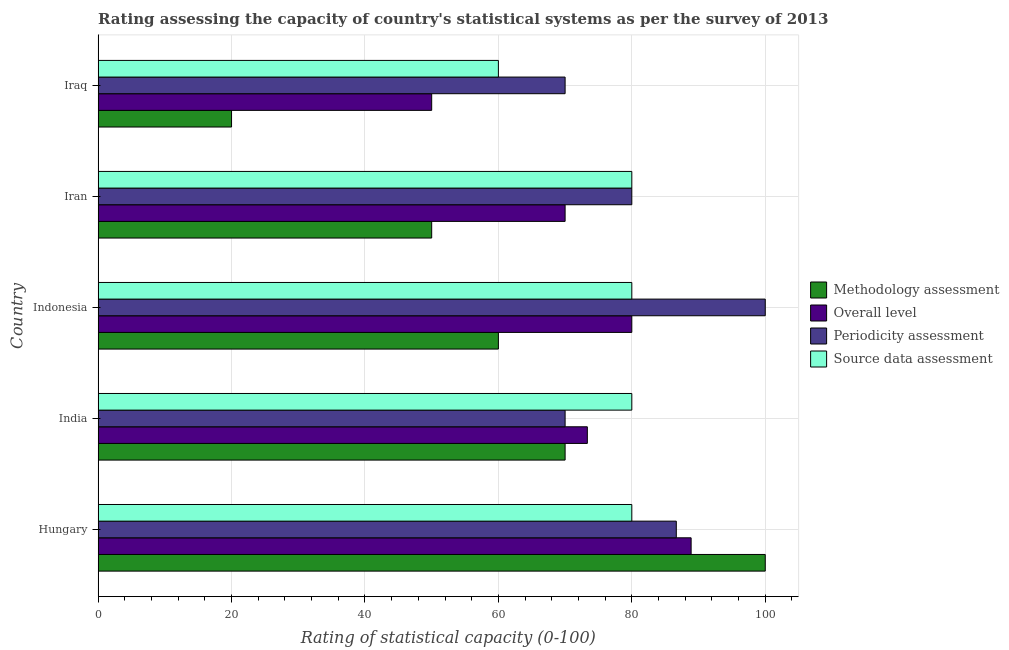How many different coloured bars are there?
Offer a very short reply. 4. How many groups of bars are there?
Make the answer very short. 5. Are the number of bars on each tick of the Y-axis equal?
Provide a short and direct response. Yes. What is the periodicity assessment rating in Hungary?
Ensure brevity in your answer.  86.67. Across all countries, what is the minimum periodicity assessment rating?
Make the answer very short. 70. In which country was the methodology assessment rating maximum?
Your answer should be compact. Hungary. In which country was the overall level rating minimum?
Keep it short and to the point. Iraq. What is the total methodology assessment rating in the graph?
Your answer should be very brief. 300. What is the difference between the methodology assessment rating in Indonesia and the overall level rating in Iraq?
Your answer should be very brief. 10. What is the ratio of the overall level rating in India to that in Iraq?
Offer a very short reply. 1.47. Is the difference between the methodology assessment rating in Hungary and Indonesia greater than the difference between the periodicity assessment rating in Hungary and Indonesia?
Your answer should be compact. Yes. What is the difference between the highest and the lowest source data assessment rating?
Make the answer very short. 20. In how many countries, is the source data assessment rating greater than the average source data assessment rating taken over all countries?
Make the answer very short. 4. What does the 3rd bar from the top in Indonesia represents?
Offer a terse response. Overall level. What does the 3rd bar from the bottom in Indonesia represents?
Make the answer very short. Periodicity assessment. Is it the case that in every country, the sum of the methodology assessment rating and overall level rating is greater than the periodicity assessment rating?
Offer a very short reply. No. How many bars are there?
Make the answer very short. 20. Are all the bars in the graph horizontal?
Keep it short and to the point. Yes. How many countries are there in the graph?
Your response must be concise. 5. What is the difference between two consecutive major ticks on the X-axis?
Ensure brevity in your answer.  20. Does the graph contain grids?
Provide a succinct answer. Yes. Where does the legend appear in the graph?
Keep it short and to the point. Center right. What is the title of the graph?
Offer a terse response. Rating assessing the capacity of country's statistical systems as per the survey of 2013 . Does "Secondary vocational" appear as one of the legend labels in the graph?
Ensure brevity in your answer.  No. What is the label or title of the X-axis?
Offer a very short reply. Rating of statistical capacity (0-100). What is the Rating of statistical capacity (0-100) of Methodology assessment in Hungary?
Your answer should be very brief. 100. What is the Rating of statistical capacity (0-100) of Overall level in Hungary?
Keep it short and to the point. 88.89. What is the Rating of statistical capacity (0-100) in Periodicity assessment in Hungary?
Your answer should be compact. 86.67. What is the Rating of statistical capacity (0-100) in Overall level in India?
Offer a very short reply. 73.33. What is the Rating of statistical capacity (0-100) in Source data assessment in India?
Give a very brief answer. 80. What is the Rating of statistical capacity (0-100) of Source data assessment in Indonesia?
Give a very brief answer. 80. What is the Rating of statistical capacity (0-100) of Periodicity assessment in Iran?
Your answer should be very brief. 80. What is the Rating of statistical capacity (0-100) of Overall level in Iraq?
Your answer should be compact. 50. What is the Rating of statistical capacity (0-100) of Periodicity assessment in Iraq?
Make the answer very short. 70. What is the Rating of statistical capacity (0-100) of Source data assessment in Iraq?
Make the answer very short. 60. Across all countries, what is the maximum Rating of statistical capacity (0-100) of Methodology assessment?
Make the answer very short. 100. Across all countries, what is the maximum Rating of statistical capacity (0-100) in Overall level?
Offer a very short reply. 88.89. Across all countries, what is the maximum Rating of statistical capacity (0-100) in Periodicity assessment?
Ensure brevity in your answer.  100. Across all countries, what is the minimum Rating of statistical capacity (0-100) in Overall level?
Offer a terse response. 50. What is the total Rating of statistical capacity (0-100) in Methodology assessment in the graph?
Make the answer very short. 300. What is the total Rating of statistical capacity (0-100) of Overall level in the graph?
Keep it short and to the point. 362.22. What is the total Rating of statistical capacity (0-100) in Periodicity assessment in the graph?
Your response must be concise. 406.67. What is the total Rating of statistical capacity (0-100) in Source data assessment in the graph?
Offer a very short reply. 380. What is the difference between the Rating of statistical capacity (0-100) in Overall level in Hungary and that in India?
Give a very brief answer. 15.56. What is the difference between the Rating of statistical capacity (0-100) of Periodicity assessment in Hungary and that in India?
Give a very brief answer. 16.67. What is the difference between the Rating of statistical capacity (0-100) of Overall level in Hungary and that in Indonesia?
Your answer should be very brief. 8.89. What is the difference between the Rating of statistical capacity (0-100) of Periodicity assessment in Hungary and that in Indonesia?
Your answer should be very brief. -13.33. What is the difference between the Rating of statistical capacity (0-100) in Methodology assessment in Hungary and that in Iran?
Provide a short and direct response. 50. What is the difference between the Rating of statistical capacity (0-100) of Overall level in Hungary and that in Iran?
Ensure brevity in your answer.  18.89. What is the difference between the Rating of statistical capacity (0-100) in Periodicity assessment in Hungary and that in Iran?
Provide a short and direct response. 6.67. What is the difference between the Rating of statistical capacity (0-100) in Source data assessment in Hungary and that in Iran?
Your answer should be compact. 0. What is the difference between the Rating of statistical capacity (0-100) in Overall level in Hungary and that in Iraq?
Your answer should be very brief. 38.89. What is the difference between the Rating of statistical capacity (0-100) of Periodicity assessment in Hungary and that in Iraq?
Your answer should be compact. 16.67. What is the difference between the Rating of statistical capacity (0-100) of Overall level in India and that in Indonesia?
Make the answer very short. -6.67. What is the difference between the Rating of statistical capacity (0-100) in Periodicity assessment in India and that in Indonesia?
Offer a very short reply. -30. What is the difference between the Rating of statistical capacity (0-100) in Methodology assessment in India and that in Iran?
Offer a terse response. 20. What is the difference between the Rating of statistical capacity (0-100) in Overall level in India and that in Iran?
Offer a terse response. 3.33. What is the difference between the Rating of statistical capacity (0-100) in Source data assessment in India and that in Iran?
Your answer should be compact. 0. What is the difference between the Rating of statistical capacity (0-100) of Methodology assessment in India and that in Iraq?
Ensure brevity in your answer.  50. What is the difference between the Rating of statistical capacity (0-100) in Overall level in India and that in Iraq?
Provide a short and direct response. 23.33. What is the difference between the Rating of statistical capacity (0-100) in Source data assessment in India and that in Iraq?
Ensure brevity in your answer.  20. What is the difference between the Rating of statistical capacity (0-100) in Methodology assessment in Indonesia and that in Iran?
Keep it short and to the point. 10. What is the difference between the Rating of statistical capacity (0-100) of Overall level in Indonesia and that in Iran?
Your response must be concise. 10. What is the difference between the Rating of statistical capacity (0-100) in Periodicity assessment in Indonesia and that in Iran?
Your answer should be very brief. 20. What is the difference between the Rating of statistical capacity (0-100) in Methodology assessment in Indonesia and that in Iraq?
Keep it short and to the point. 40. What is the difference between the Rating of statistical capacity (0-100) in Overall level in Indonesia and that in Iraq?
Your response must be concise. 30. What is the difference between the Rating of statistical capacity (0-100) in Source data assessment in Indonesia and that in Iraq?
Your answer should be very brief. 20. What is the difference between the Rating of statistical capacity (0-100) of Methodology assessment in Iran and that in Iraq?
Provide a short and direct response. 30. What is the difference between the Rating of statistical capacity (0-100) of Periodicity assessment in Iran and that in Iraq?
Offer a terse response. 10. What is the difference between the Rating of statistical capacity (0-100) in Methodology assessment in Hungary and the Rating of statistical capacity (0-100) in Overall level in India?
Provide a succinct answer. 26.67. What is the difference between the Rating of statistical capacity (0-100) in Overall level in Hungary and the Rating of statistical capacity (0-100) in Periodicity assessment in India?
Offer a very short reply. 18.89. What is the difference between the Rating of statistical capacity (0-100) in Overall level in Hungary and the Rating of statistical capacity (0-100) in Source data assessment in India?
Your answer should be very brief. 8.89. What is the difference between the Rating of statistical capacity (0-100) in Methodology assessment in Hungary and the Rating of statistical capacity (0-100) in Source data assessment in Indonesia?
Offer a very short reply. 20. What is the difference between the Rating of statistical capacity (0-100) of Overall level in Hungary and the Rating of statistical capacity (0-100) of Periodicity assessment in Indonesia?
Offer a terse response. -11.11. What is the difference between the Rating of statistical capacity (0-100) of Overall level in Hungary and the Rating of statistical capacity (0-100) of Source data assessment in Indonesia?
Keep it short and to the point. 8.89. What is the difference between the Rating of statistical capacity (0-100) in Periodicity assessment in Hungary and the Rating of statistical capacity (0-100) in Source data assessment in Indonesia?
Your answer should be very brief. 6.67. What is the difference between the Rating of statistical capacity (0-100) in Methodology assessment in Hungary and the Rating of statistical capacity (0-100) in Periodicity assessment in Iran?
Keep it short and to the point. 20. What is the difference between the Rating of statistical capacity (0-100) of Methodology assessment in Hungary and the Rating of statistical capacity (0-100) of Source data assessment in Iran?
Offer a very short reply. 20. What is the difference between the Rating of statistical capacity (0-100) in Overall level in Hungary and the Rating of statistical capacity (0-100) in Periodicity assessment in Iran?
Keep it short and to the point. 8.89. What is the difference between the Rating of statistical capacity (0-100) of Overall level in Hungary and the Rating of statistical capacity (0-100) of Source data assessment in Iran?
Make the answer very short. 8.89. What is the difference between the Rating of statistical capacity (0-100) of Methodology assessment in Hungary and the Rating of statistical capacity (0-100) of Source data assessment in Iraq?
Make the answer very short. 40. What is the difference between the Rating of statistical capacity (0-100) of Overall level in Hungary and the Rating of statistical capacity (0-100) of Periodicity assessment in Iraq?
Offer a terse response. 18.89. What is the difference between the Rating of statistical capacity (0-100) in Overall level in Hungary and the Rating of statistical capacity (0-100) in Source data assessment in Iraq?
Keep it short and to the point. 28.89. What is the difference between the Rating of statistical capacity (0-100) in Periodicity assessment in Hungary and the Rating of statistical capacity (0-100) in Source data assessment in Iraq?
Provide a succinct answer. 26.67. What is the difference between the Rating of statistical capacity (0-100) of Methodology assessment in India and the Rating of statistical capacity (0-100) of Overall level in Indonesia?
Keep it short and to the point. -10. What is the difference between the Rating of statistical capacity (0-100) in Methodology assessment in India and the Rating of statistical capacity (0-100) in Source data assessment in Indonesia?
Keep it short and to the point. -10. What is the difference between the Rating of statistical capacity (0-100) in Overall level in India and the Rating of statistical capacity (0-100) in Periodicity assessment in Indonesia?
Ensure brevity in your answer.  -26.67. What is the difference between the Rating of statistical capacity (0-100) in Overall level in India and the Rating of statistical capacity (0-100) in Source data assessment in Indonesia?
Offer a terse response. -6.67. What is the difference between the Rating of statistical capacity (0-100) in Periodicity assessment in India and the Rating of statistical capacity (0-100) in Source data assessment in Indonesia?
Provide a short and direct response. -10. What is the difference between the Rating of statistical capacity (0-100) in Methodology assessment in India and the Rating of statistical capacity (0-100) in Periodicity assessment in Iran?
Keep it short and to the point. -10. What is the difference between the Rating of statistical capacity (0-100) of Overall level in India and the Rating of statistical capacity (0-100) of Periodicity assessment in Iran?
Keep it short and to the point. -6.67. What is the difference between the Rating of statistical capacity (0-100) of Overall level in India and the Rating of statistical capacity (0-100) of Source data assessment in Iran?
Keep it short and to the point. -6.67. What is the difference between the Rating of statistical capacity (0-100) of Methodology assessment in India and the Rating of statistical capacity (0-100) of Source data assessment in Iraq?
Ensure brevity in your answer.  10. What is the difference between the Rating of statistical capacity (0-100) of Overall level in India and the Rating of statistical capacity (0-100) of Source data assessment in Iraq?
Your response must be concise. 13.33. What is the difference between the Rating of statistical capacity (0-100) in Methodology assessment in Indonesia and the Rating of statistical capacity (0-100) in Overall level in Iran?
Keep it short and to the point. -10. What is the difference between the Rating of statistical capacity (0-100) in Methodology assessment in Indonesia and the Rating of statistical capacity (0-100) in Periodicity assessment in Iran?
Your answer should be compact. -20. What is the difference between the Rating of statistical capacity (0-100) of Overall level in Indonesia and the Rating of statistical capacity (0-100) of Source data assessment in Iran?
Provide a succinct answer. 0. What is the difference between the Rating of statistical capacity (0-100) of Overall level in Indonesia and the Rating of statistical capacity (0-100) of Source data assessment in Iraq?
Offer a very short reply. 20. What is the difference between the Rating of statistical capacity (0-100) of Periodicity assessment in Indonesia and the Rating of statistical capacity (0-100) of Source data assessment in Iraq?
Your answer should be very brief. 40. What is the difference between the Rating of statistical capacity (0-100) in Methodology assessment in Iran and the Rating of statistical capacity (0-100) in Overall level in Iraq?
Your response must be concise. 0. What is the difference between the Rating of statistical capacity (0-100) in Overall level in Iran and the Rating of statistical capacity (0-100) in Source data assessment in Iraq?
Keep it short and to the point. 10. What is the difference between the Rating of statistical capacity (0-100) of Periodicity assessment in Iran and the Rating of statistical capacity (0-100) of Source data assessment in Iraq?
Your response must be concise. 20. What is the average Rating of statistical capacity (0-100) in Methodology assessment per country?
Ensure brevity in your answer.  60. What is the average Rating of statistical capacity (0-100) in Overall level per country?
Provide a short and direct response. 72.44. What is the average Rating of statistical capacity (0-100) of Periodicity assessment per country?
Ensure brevity in your answer.  81.33. What is the difference between the Rating of statistical capacity (0-100) of Methodology assessment and Rating of statistical capacity (0-100) of Overall level in Hungary?
Provide a succinct answer. 11.11. What is the difference between the Rating of statistical capacity (0-100) in Methodology assessment and Rating of statistical capacity (0-100) in Periodicity assessment in Hungary?
Offer a terse response. 13.33. What is the difference between the Rating of statistical capacity (0-100) in Methodology assessment and Rating of statistical capacity (0-100) in Source data assessment in Hungary?
Give a very brief answer. 20. What is the difference between the Rating of statistical capacity (0-100) in Overall level and Rating of statistical capacity (0-100) in Periodicity assessment in Hungary?
Offer a terse response. 2.22. What is the difference between the Rating of statistical capacity (0-100) of Overall level and Rating of statistical capacity (0-100) of Source data assessment in Hungary?
Your answer should be very brief. 8.89. What is the difference between the Rating of statistical capacity (0-100) of Methodology assessment and Rating of statistical capacity (0-100) of Overall level in India?
Give a very brief answer. -3.33. What is the difference between the Rating of statistical capacity (0-100) in Methodology assessment and Rating of statistical capacity (0-100) in Source data assessment in India?
Your answer should be very brief. -10. What is the difference between the Rating of statistical capacity (0-100) of Overall level and Rating of statistical capacity (0-100) of Source data assessment in India?
Provide a short and direct response. -6.67. What is the difference between the Rating of statistical capacity (0-100) in Methodology assessment and Rating of statistical capacity (0-100) in Overall level in Indonesia?
Provide a short and direct response. -20. What is the difference between the Rating of statistical capacity (0-100) in Methodology assessment and Rating of statistical capacity (0-100) in Source data assessment in Indonesia?
Offer a very short reply. -20. What is the difference between the Rating of statistical capacity (0-100) in Periodicity assessment and Rating of statistical capacity (0-100) in Source data assessment in Indonesia?
Your response must be concise. 20. What is the difference between the Rating of statistical capacity (0-100) in Methodology assessment and Rating of statistical capacity (0-100) in Overall level in Iran?
Give a very brief answer. -20. What is the difference between the Rating of statistical capacity (0-100) in Methodology assessment and Rating of statistical capacity (0-100) in Periodicity assessment in Iran?
Provide a short and direct response. -30. What is the difference between the Rating of statistical capacity (0-100) of Methodology assessment and Rating of statistical capacity (0-100) of Source data assessment in Iran?
Make the answer very short. -30. What is the difference between the Rating of statistical capacity (0-100) of Methodology assessment and Rating of statistical capacity (0-100) of Source data assessment in Iraq?
Your response must be concise. -40. What is the difference between the Rating of statistical capacity (0-100) in Overall level and Rating of statistical capacity (0-100) in Periodicity assessment in Iraq?
Provide a short and direct response. -20. What is the difference between the Rating of statistical capacity (0-100) in Overall level and Rating of statistical capacity (0-100) in Source data assessment in Iraq?
Make the answer very short. -10. What is the difference between the Rating of statistical capacity (0-100) in Periodicity assessment and Rating of statistical capacity (0-100) in Source data assessment in Iraq?
Make the answer very short. 10. What is the ratio of the Rating of statistical capacity (0-100) of Methodology assessment in Hungary to that in India?
Give a very brief answer. 1.43. What is the ratio of the Rating of statistical capacity (0-100) in Overall level in Hungary to that in India?
Keep it short and to the point. 1.21. What is the ratio of the Rating of statistical capacity (0-100) in Periodicity assessment in Hungary to that in India?
Your answer should be compact. 1.24. What is the ratio of the Rating of statistical capacity (0-100) in Methodology assessment in Hungary to that in Indonesia?
Your answer should be compact. 1.67. What is the ratio of the Rating of statistical capacity (0-100) of Overall level in Hungary to that in Indonesia?
Offer a very short reply. 1.11. What is the ratio of the Rating of statistical capacity (0-100) in Periodicity assessment in Hungary to that in Indonesia?
Your response must be concise. 0.87. What is the ratio of the Rating of statistical capacity (0-100) in Source data assessment in Hungary to that in Indonesia?
Ensure brevity in your answer.  1. What is the ratio of the Rating of statistical capacity (0-100) of Methodology assessment in Hungary to that in Iran?
Your response must be concise. 2. What is the ratio of the Rating of statistical capacity (0-100) in Overall level in Hungary to that in Iran?
Provide a short and direct response. 1.27. What is the ratio of the Rating of statistical capacity (0-100) of Methodology assessment in Hungary to that in Iraq?
Make the answer very short. 5. What is the ratio of the Rating of statistical capacity (0-100) of Overall level in Hungary to that in Iraq?
Offer a terse response. 1.78. What is the ratio of the Rating of statistical capacity (0-100) in Periodicity assessment in Hungary to that in Iraq?
Your answer should be very brief. 1.24. What is the ratio of the Rating of statistical capacity (0-100) of Source data assessment in Hungary to that in Iraq?
Keep it short and to the point. 1.33. What is the ratio of the Rating of statistical capacity (0-100) in Overall level in India to that in Indonesia?
Keep it short and to the point. 0.92. What is the ratio of the Rating of statistical capacity (0-100) of Periodicity assessment in India to that in Indonesia?
Provide a succinct answer. 0.7. What is the ratio of the Rating of statistical capacity (0-100) of Source data assessment in India to that in Indonesia?
Your answer should be very brief. 1. What is the ratio of the Rating of statistical capacity (0-100) of Overall level in India to that in Iran?
Your response must be concise. 1.05. What is the ratio of the Rating of statistical capacity (0-100) of Periodicity assessment in India to that in Iran?
Make the answer very short. 0.88. What is the ratio of the Rating of statistical capacity (0-100) in Source data assessment in India to that in Iran?
Provide a succinct answer. 1. What is the ratio of the Rating of statistical capacity (0-100) in Overall level in India to that in Iraq?
Your answer should be very brief. 1.47. What is the ratio of the Rating of statistical capacity (0-100) in Source data assessment in India to that in Iraq?
Ensure brevity in your answer.  1.33. What is the ratio of the Rating of statistical capacity (0-100) of Methodology assessment in Indonesia to that in Iran?
Your answer should be very brief. 1.2. What is the ratio of the Rating of statistical capacity (0-100) of Overall level in Indonesia to that in Iran?
Make the answer very short. 1.14. What is the ratio of the Rating of statistical capacity (0-100) of Periodicity assessment in Indonesia to that in Iran?
Your answer should be compact. 1.25. What is the ratio of the Rating of statistical capacity (0-100) of Source data assessment in Indonesia to that in Iran?
Make the answer very short. 1. What is the ratio of the Rating of statistical capacity (0-100) in Methodology assessment in Indonesia to that in Iraq?
Give a very brief answer. 3. What is the ratio of the Rating of statistical capacity (0-100) in Periodicity assessment in Indonesia to that in Iraq?
Keep it short and to the point. 1.43. What is the ratio of the Rating of statistical capacity (0-100) in Source data assessment in Indonesia to that in Iraq?
Your answer should be very brief. 1.33. What is the ratio of the Rating of statistical capacity (0-100) in Methodology assessment in Iran to that in Iraq?
Your answer should be compact. 2.5. What is the ratio of the Rating of statistical capacity (0-100) of Overall level in Iran to that in Iraq?
Give a very brief answer. 1.4. What is the ratio of the Rating of statistical capacity (0-100) in Periodicity assessment in Iran to that in Iraq?
Ensure brevity in your answer.  1.14. What is the ratio of the Rating of statistical capacity (0-100) in Source data assessment in Iran to that in Iraq?
Offer a terse response. 1.33. What is the difference between the highest and the second highest Rating of statistical capacity (0-100) in Methodology assessment?
Offer a very short reply. 30. What is the difference between the highest and the second highest Rating of statistical capacity (0-100) in Overall level?
Give a very brief answer. 8.89. What is the difference between the highest and the second highest Rating of statistical capacity (0-100) of Periodicity assessment?
Keep it short and to the point. 13.33. What is the difference between the highest and the second highest Rating of statistical capacity (0-100) in Source data assessment?
Keep it short and to the point. 0. What is the difference between the highest and the lowest Rating of statistical capacity (0-100) of Methodology assessment?
Provide a short and direct response. 80. What is the difference between the highest and the lowest Rating of statistical capacity (0-100) of Overall level?
Provide a succinct answer. 38.89. 